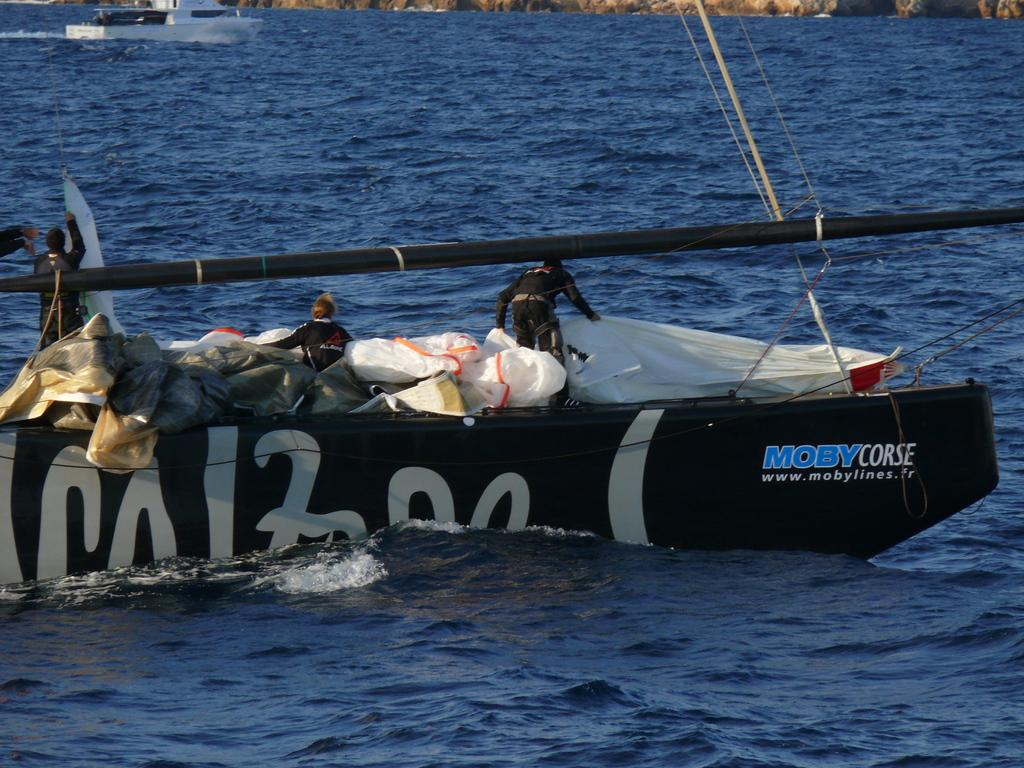How many people are in the image? There are three people in the image. What are the people doing in the image? The people are in a boat. What else can be seen in the boat besides the people? There are sheets in the boat. Can you describe the other boat visible in the image? There is another boat visible in the image, but no specific details about it are provided. What color is the water in the image? The water in the image is blue. What type of polish is being applied to the son's twist in the image? There is no mention of polish, a son, or a twist in the image; it features three people in a boat with sheets and another boat in the background. 